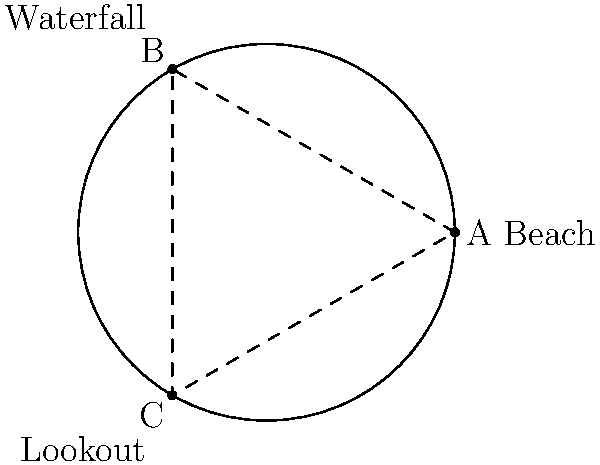You're planning a road trip on a circular island with a radius of 10 km. There are three main attractions: a beach at $(10, 0)$, a waterfall at $(5, 8.66)$, and a scenic lookout at $(-5, -8.66)$ in Cartesian coordinates. If you start at the beach and want to visit all attractions in the most efficient order, what is the total distance traveled in kilometers, rounded to the nearest whole number? To solve this problem, we'll follow these steps:

1) First, let's convert the Cartesian coordinates to polar coordinates:
   Beach: $(10, 0) \rightarrow (10, 0°)$
   Waterfall: $(5, 8.66) \rightarrow (10, 60°)$
   Lookout: $(-5, -8.66) \rightarrow (10, 240°)$

2) Now, we need to determine the most efficient order. The shortest path will be the one that follows the circular path of the island in one direction.

3) Starting from the beach (0°), we have two options:
   a) Beach (0°) → Waterfall (60°) → Lookout (240°) → Beach (360°)
   b) Beach (0°) → Lookout (240°) → Waterfall (300°) → Beach (360°)

4) Let's calculate the angular distances for both:
   a) 60° + 180° + 120° = 360°
   b) 240° + 60° + 60° = 360°

   Both paths result in a full 360° rotation, so they're equivalent in distance.

5) To calculate the actual distance, we use the formula for arc length:
   $s = r\theta$, where $r$ is the radius and $\theta$ is the angle in radians.

6) Convert 360° to radians: $360° \times \frac{\pi}{180°} = 2\pi$ radians

7) Calculate the distance: $s = 10 \times 2\pi = 20\pi$ km

8) Round to the nearest whole number: $20\pi \approx 63$ km

Therefore, the total distance traveled is approximately 63 km.
Answer: 63 km 